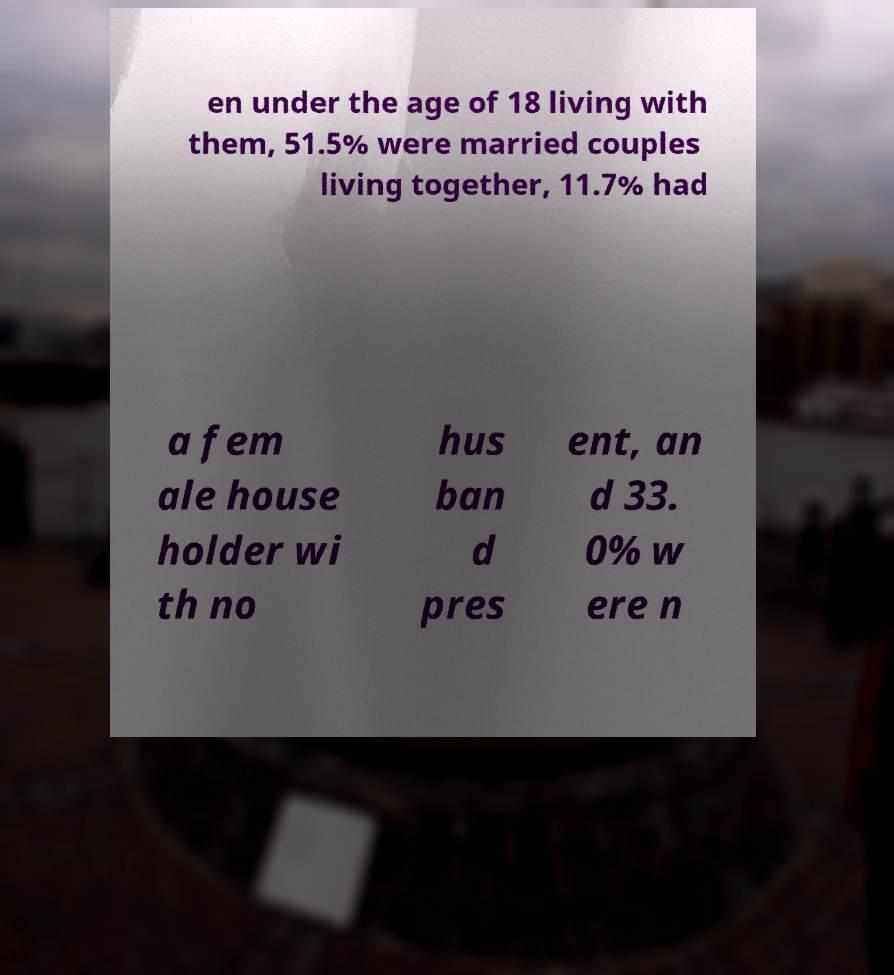I need the written content from this picture converted into text. Can you do that? en under the age of 18 living with them, 51.5% were married couples living together, 11.7% had a fem ale house holder wi th no hus ban d pres ent, an d 33. 0% w ere n 